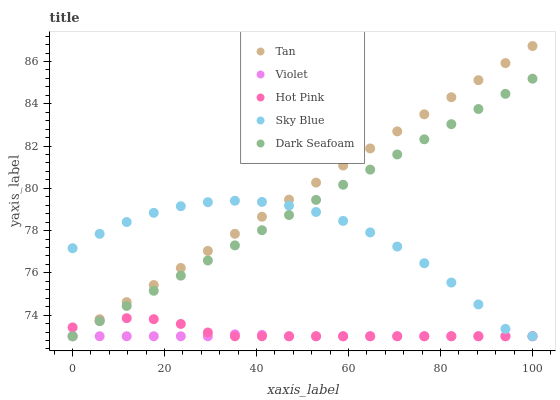Does Violet have the minimum area under the curve?
Answer yes or no. Yes. Does Tan have the maximum area under the curve?
Answer yes or no. Yes. Does Hot Pink have the minimum area under the curve?
Answer yes or no. No. Does Hot Pink have the maximum area under the curve?
Answer yes or no. No. Is Dark Seafoam the smoothest?
Answer yes or no. Yes. Is Sky Blue the roughest?
Answer yes or no. Yes. Is Tan the smoothest?
Answer yes or no. No. Is Tan the roughest?
Answer yes or no. No. Does Sky Blue have the lowest value?
Answer yes or no. Yes. Does Tan have the highest value?
Answer yes or no. Yes. Does Hot Pink have the highest value?
Answer yes or no. No. Does Sky Blue intersect Violet?
Answer yes or no. Yes. Is Sky Blue less than Violet?
Answer yes or no. No. Is Sky Blue greater than Violet?
Answer yes or no. No. 